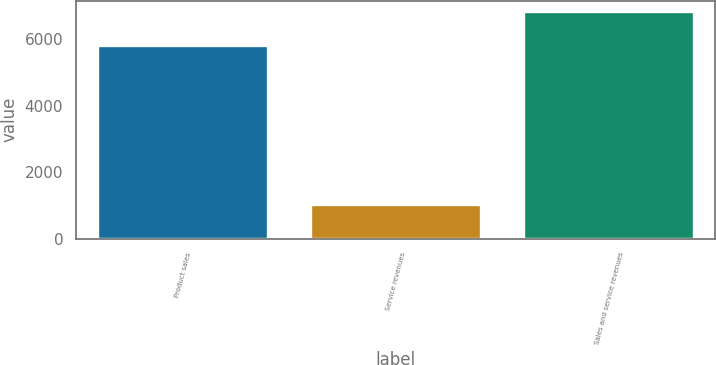Convert chart to OTSL. <chart><loc_0><loc_0><loc_500><loc_500><bar_chart><fcel>Product sales<fcel>Service revenues<fcel>Sales and service revenues<nl><fcel>5801<fcel>1019<fcel>6820<nl></chart> 